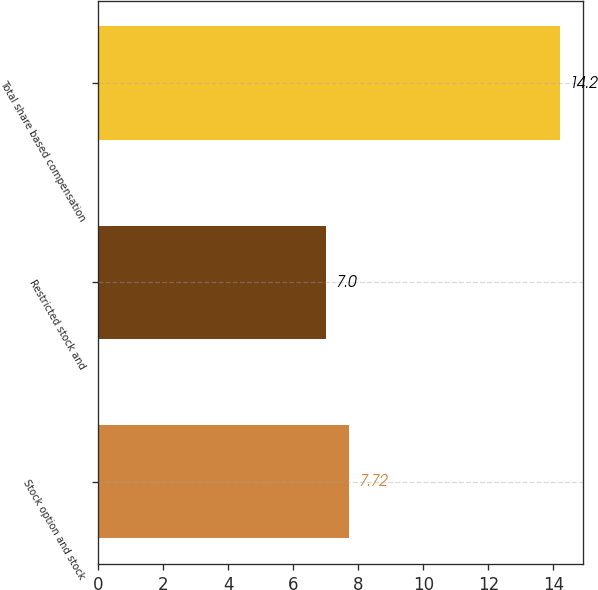Convert chart to OTSL. <chart><loc_0><loc_0><loc_500><loc_500><bar_chart><fcel>Stock option and stock<fcel>Restricted stock and<fcel>Total share based compensation<nl><fcel>7.72<fcel>7<fcel>14.2<nl></chart> 